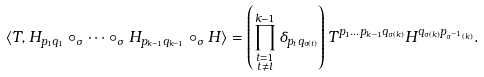Convert formula to latex. <formula><loc_0><loc_0><loc_500><loc_500>\langle T , H _ { p _ { 1 } q _ { 1 } } & \circ _ { \sigma } \cdots \circ _ { \sigma } H _ { p _ { k - 1 } q _ { k - 1 } } \circ _ { \sigma } H \rangle = \left ( \prod _ { \substack { t = 1 \\ t \not = l } } ^ { k - 1 } \delta _ { p _ { t } q _ { \sigma ( t ) } } \right ) T ^ { p _ { 1 } \dots p _ { k - 1 } q _ { \sigma ( k ) } } H ^ { q _ { \sigma ( k ) } p _ { \sigma ^ { - 1 } ( k ) } } .</formula> 